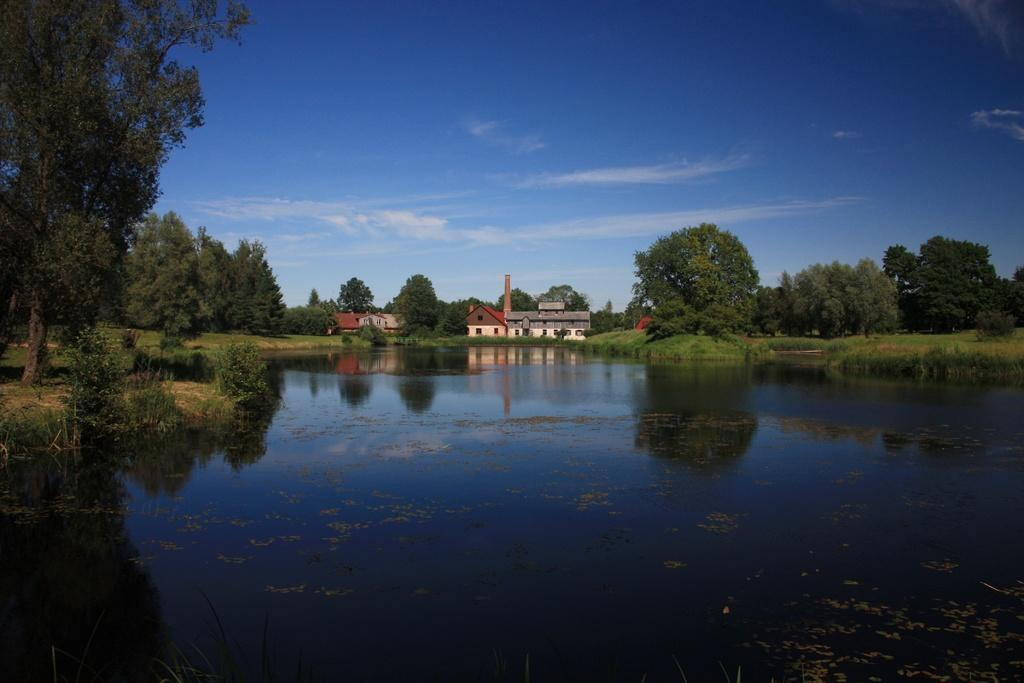What is at the bottom of the image? There is water at the bottom of the image. What can be seen in the background of the image? There are trees, houses, and grass in the background of the image. What is visible at the top of the image? The sky is visible at the top of the image. How many giants can be seen walking through the grass in the image? There are no giants present in the image; it features water, trees, houses, grass, and the sky. What type of step is used to climb the trees in the image? There are no steps or people climbing trees in the image; it only shows water, trees, houses, grass, and the sky. 